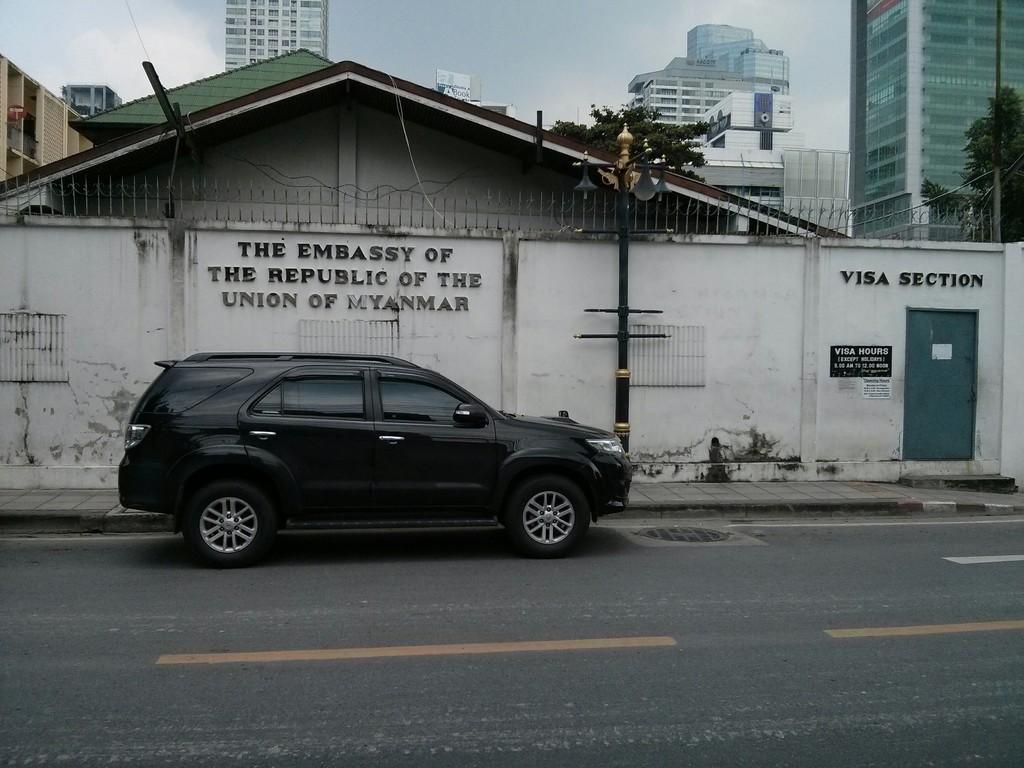In one or two sentences, can you explain what this image depicts? In this image, I can see a car on the road. There are buildings, trees and I can see the lights to a pole. In the background, there is the sky. I can see a name board attached to the building wall. 